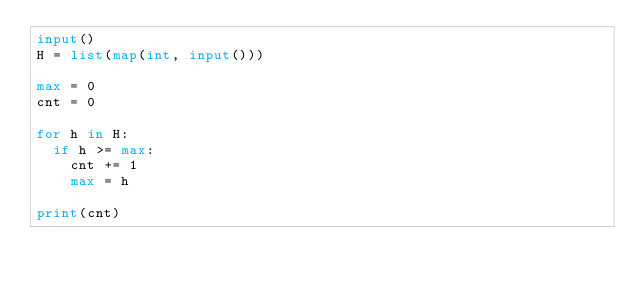<code> <loc_0><loc_0><loc_500><loc_500><_Python_>input()
H = list(map(int, input()))

max = 0
cnt = 0

for h in H:
  if h >= max:
    cnt += 1
    max = h

print(cnt)</code> 